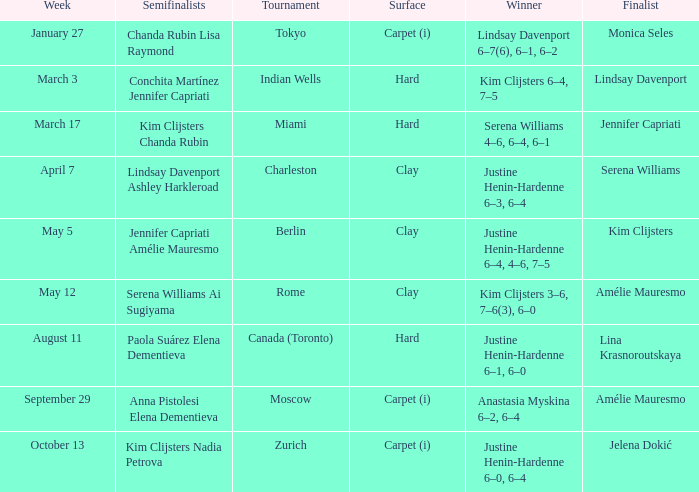Who was the finalist in Miami? Jennifer Capriati. 